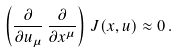Convert formula to latex. <formula><loc_0><loc_0><loc_500><loc_500>\left ( \frac { \partial } { \partial u _ { \mu } } \, \frac { \partial } { \partial x ^ { \mu } } \right ) \, J ( x , u ) \approx 0 \, .</formula> 